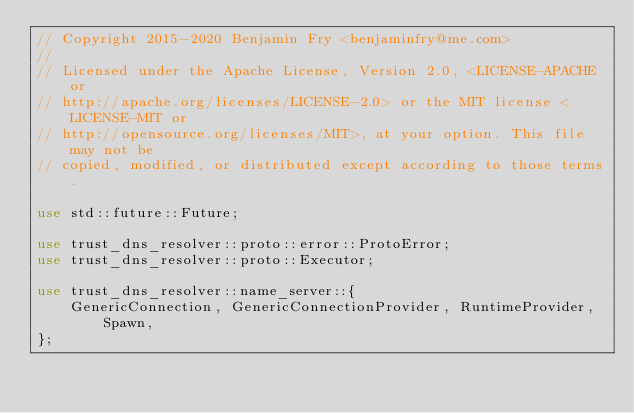Convert code to text. <code><loc_0><loc_0><loc_500><loc_500><_Rust_>// Copyright 2015-2020 Benjamin Fry <benjaminfry@me.com>
//
// Licensed under the Apache License, Version 2.0, <LICENSE-APACHE or
// http://apache.org/licenses/LICENSE-2.0> or the MIT license <LICENSE-MIT or
// http://opensource.org/licenses/MIT>, at your option. This file may not be
// copied, modified, or distributed except according to those terms.

use std::future::Future;

use trust_dns_resolver::proto::error::ProtoError;
use trust_dns_resolver::proto::Executor;

use trust_dns_resolver::name_server::{
    GenericConnection, GenericConnectionProvider, RuntimeProvider, Spawn,
};
</code> 